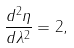<formula> <loc_0><loc_0><loc_500><loc_500>\frac { d ^ { 2 } \eta } { d \lambda ^ { 2 } } = 2 ,</formula> 